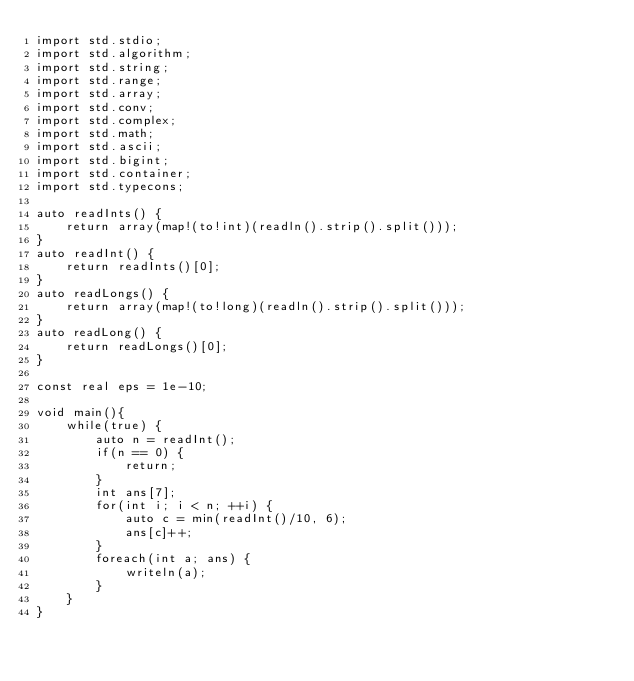Convert code to text. <code><loc_0><loc_0><loc_500><loc_500><_D_>import std.stdio;
import std.algorithm;
import std.string;
import std.range;
import std.array;
import std.conv;
import std.complex;
import std.math;
import std.ascii;
import std.bigint;
import std.container;
import std.typecons;

auto readInts() {
	return array(map!(to!int)(readln().strip().split()));
}
auto readInt() {
	return readInts()[0];
}
auto readLongs() {
	return array(map!(to!long)(readln().strip().split()));
}
auto readLong() {
	return readLongs()[0];
}

const real eps = 1e-10;

void main(){
	while(true) {
		auto n = readInt();
		if(n == 0) {
			return;
		}
		int ans[7];
		for(int i; i < n; ++i) {
			auto c = min(readInt()/10, 6);
			ans[c]++;
		}
		foreach(int a; ans) {
			writeln(a);
		}
	}
}</code> 